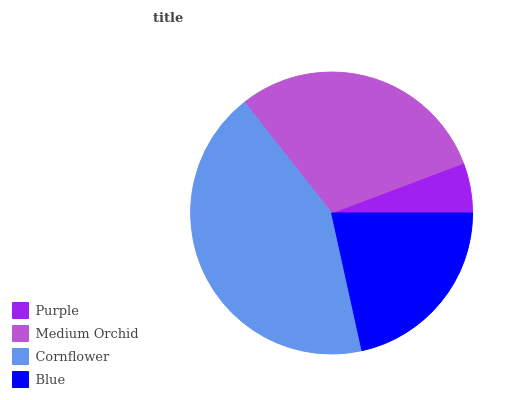Is Purple the minimum?
Answer yes or no. Yes. Is Cornflower the maximum?
Answer yes or no. Yes. Is Medium Orchid the minimum?
Answer yes or no. No. Is Medium Orchid the maximum?
Answer yes or no. No. Is Medium Orchid greater than Purple?
Answer yes or no. Yes. Is Purple less than Medium Orchid?
Answer yes or no. Yes. Is Purple greater than Medium Orchid?
Answer yes or no. No. Is Medium Orchid less than Purple?
Answer yes or no. No. Is Medium Orchid the high median?
Answer yes or no. Yes. Is Blue the low median?
Answer yes or no. Yes. Is Cornflower the high median?
Answer yes or no. No. Is Cornflower the low median?
Answer yes or no. No. 